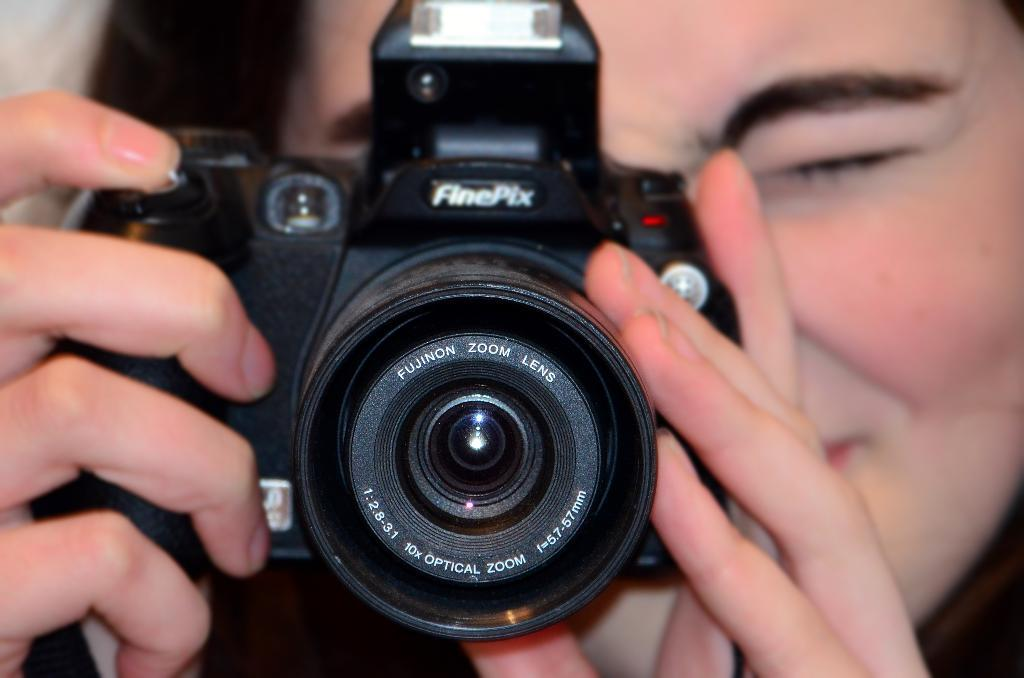What is the main subject of the image? There is a person in the image. What is the person holding in the image? The person is holding a camera. What type of story is the person telling to the fairies in the image? There are no fairies present in the image, and the person is holding a camera, not telling a story. 